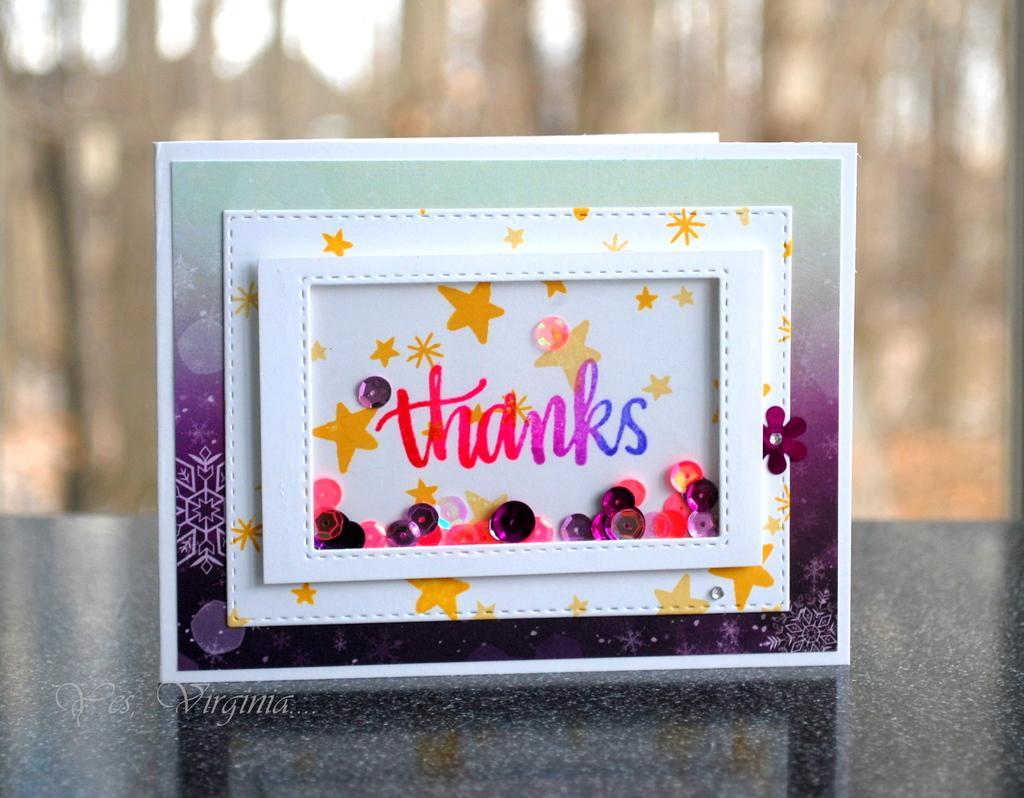In one or two sentences, can you explain what this image depicts? In this picture we can see some boards, on which we can see some text. 